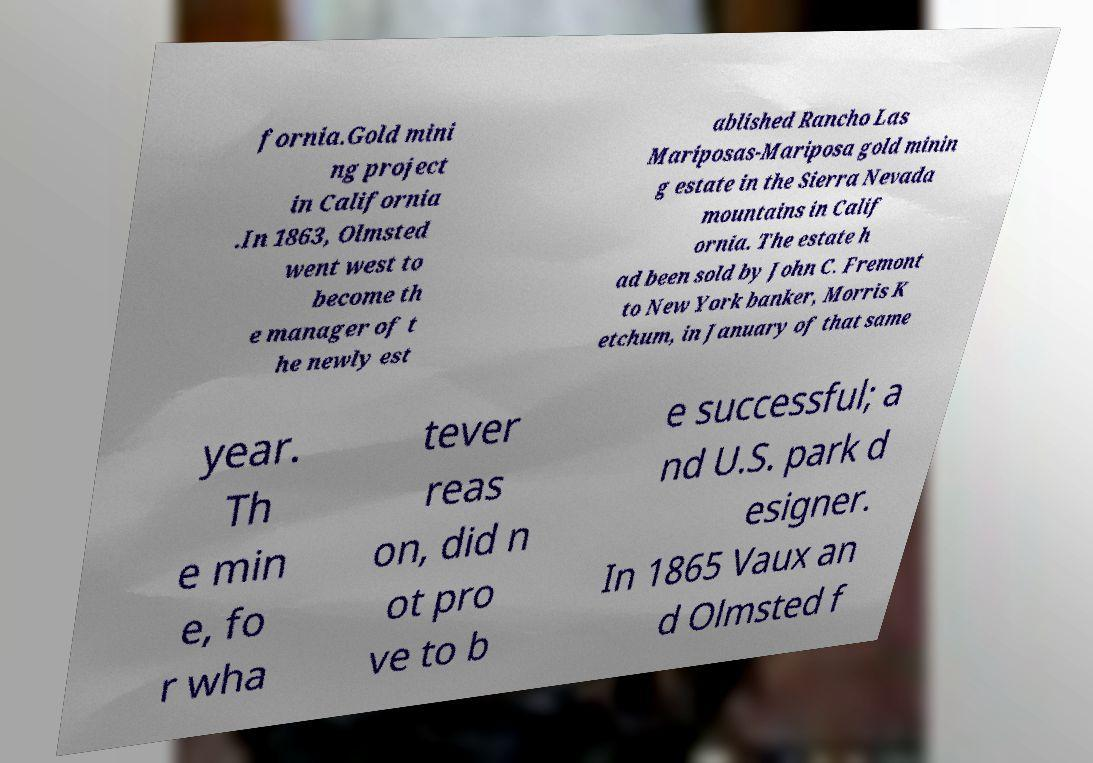Could you assist in decoding the text presented in this image and type it out clearly? fornia.Gold mini ng project in California .In 1863, Olmsted went west to become th e manager of t he newly est ablished Rancho Las Mariposas-Mariposa gold minin g estate in the Sierra Nevada mountains in Calif ornia. The estate h ad been sold by John C. Fremont to New York banker, Morris K etchum, in January of that same year. Th e min e, fo r wha tever reas on, did n ot pro ve to b e successful; a nd U.S. park d esigner. In 1865 Vaux an d Olmsted f 